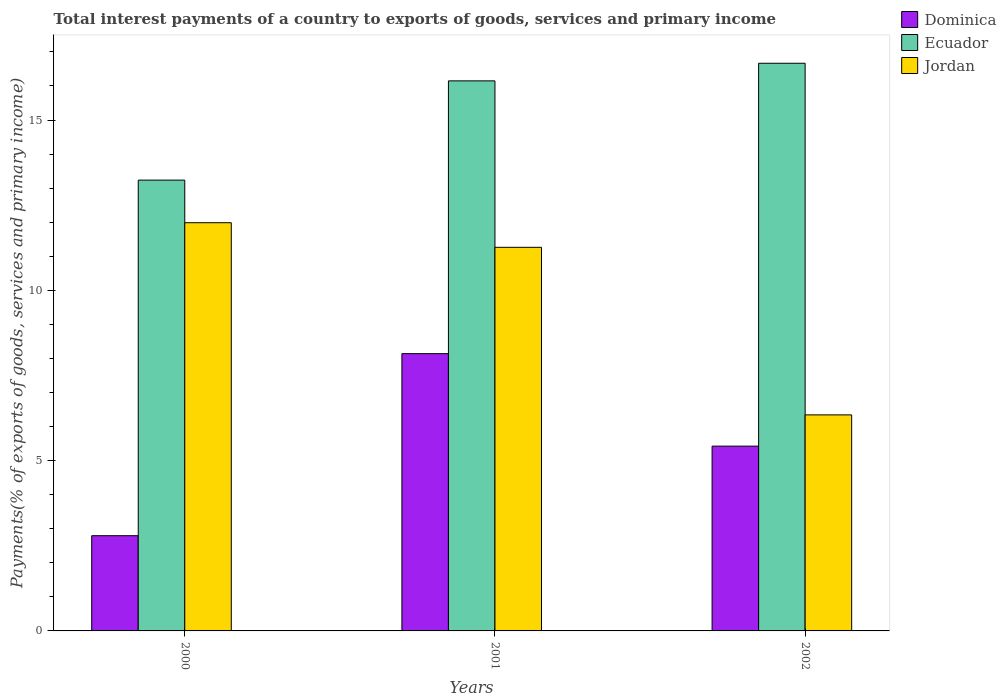How many groups of bars are there?
Ensure brevity in your answer.  3. Are the number of bars on each tick of the X-axis equal?
Your answer should be compact. Yes. How many bars are there on the 2nd tick from the right?
Keep it short and to the point. 3. What is the label of the 3rd group of bars from the left?
Make the answer very short. 2002. What is the total interest payments in Dominica in 2001?
Give a very brief answer. 8.14. Across all years, what is the maximum total interest payments in Jordan?
Ensure brevity in your answer.  11.99. Across all years, what is the minimum total interest payments in Dominica?
Make the answer very short. 2.8. What is the total total interest payments in Jordan in the graph?
Your answer should be very brief. 29.59. What is the difference between the total interest payments in Ecuador in 2001 and that in 2002?
Your answer should be compact. -0.52. What is the difference between the total interest payments in Ecuador in 2000 and the total interest payments in Jordan in 2001?
Offer a terse response. 1.97. What is the average total interest payments in Jordan per year?
Your answer should be very brief. 9.86. In the year 2002, what is the difference between the total interest payments in Dominica and total interest payments in Ecuador?
Provide a short and direct response. -11.24. What is the ratio of the total interest payments in Ecuador in 2001 to that in 2002?
Ensure brevity in your answer.  0.97. Is the total interest payments in Ecuador in 2000 less than that in 2001?
Ensure brevity in your answer.  Yes. Is the difference between the total interest payments in Dominica in 2001 and 2002 greater than the difference between the total interest payments in Ecuador in 2001 and 2002?
Your answer should be compact. Yes. What is the difference between the highest and the second highest total interest payments in Dominica?
Your answer should be compact. 2.72. What is the difference between the highest and the lowest total interest payments in Jordan?
Your response must be concise. 5.64. In how many years, is the total interest payments in Jordan greater than the average total interest payments in Jordan taken over all years?
Keep it short and to the point. 2. Is the sum of the total interest payments in Dominica in 2000 and 2002 greater than the maximum total interest payments in Ecuador across all years?
Provide a succinct answer. No. What does the 1st bar from the left in 2002 represents?
Your response must be concise. Dominica. What does the 3rd bar from the right in 2001 represents?
Your answer should be very brief. Dominica. Are all the bars in the graph horizontal?
Ensure brevity in your answer.  No. What is the difference between two consecutive major ticks on the Y-axis?
Your answer should be very brief. 5. Are the values on the major ticks of Y-axis written in scientific E-notation?
Keep it short and to the point. No. Where does the legend appear in the graph?
Your answer should be compact. Top right. How are the legend labels stacked?
Give a very brief answer. Vertical. What is the title of the graph?
Provide a succinct answer. Total interest payments of a country to exports of goods, services and primary income. Does "Least developed countries" appear as one of the legend labels in the graph?
Keep it short and to the point. No. What is the label or title of the Y-axis?
Your answer should be very brief. Payments(% of exports of goods, services and primary income). What is the Payments(% of exports of goods, services and primary income) in Dominica in 2000?
Give a very brief answer. 2.8. What is the Payments(% of exports of goods, services and primary income) of Ecuador in 2000?
Keep it short and to the point. 13.24. What is the Payments(% of exports of goods, services and primary income) in Jordan in 2000?
Your answer should be very brief. 11.99. What is the Payments(% of exports of goods, services and primary income) in Dominica in 2001?
Provide a succinct answer. 8.14. What is the Payments(% of exports of goods, services and primary income) of Ecuador in 2001?
Provide a short and direct response. 16.15. What is the Payments(% of exports of goods, services and primary income) of Jordan in 2001?
Provide a short and direct response. 11.26. What is the Payments(% of exports of goods, services and primary income) of Dominica in 2002?
Give a very brief answer. 5.43. What is the Payments(% of exports of goods, services and primary income) of Ecuador in 2002?
Provide a succinct answer. 16.67. What is the Payments(% of exports of goods, services and primary income) in Jordan in 2002?
Give a very brief answer. 6.34. Across all years, what is the maximum Payments(% of exports of goods, services and primary income) of Dominica?
Keep it short and to the point. 8.14. Across all years, what is the maximum Payments(% of exports of goods, services and primary income) of Ecuador?
Give a very brief answer. 16.67. Across all years, what is the maximum Payments(% of exports of goods, services and primary income) of Jordan?
Offer a terse response. 11.99. Across all years, what is the minimum Payments(% of exports of goods, services and primary income) of Dominica?
Keep it short and to the point. 2.8. Across all years, what is the minimum Payments(% of exports of goods, services and primary income) in Ecuador?
Give a very brief answer. 13.24. Across all years, what is the minimum Payments(% of exports of goods, services and primary income) in Jordan?
Your answer should be compact. 6.34. What is the total Payments(% of exports of goods, services and primary income) in Dominica in the graph?
Your answer should be very brief. 16.36. What is the total Payments(% of exports of goods, services and primary income) in Ecuador in the graph?
Give a very brief answer. 46.05. What is the total Payments(% of exports of goods, services and primary income) in Jordan in the graph?
Give a very brief answer. 29.59. What is the difference between the Payments(% of exports of goods, services and primary income) of Dominica in 2000 and that in 2001?
Your answer should be compact. -5.35. What is the difference between the Payments(% of exports of goods, services and primary income) of Ecuador in 2000 and that in 2001?
Offer a terse response. -2.91. What is the difference between the Payments(% of exports of goods, services and primary income) in Jordan in 2000 and that in 2001?
Offer a very short reply. 0.72. What is the difference between the Payments(% of exports of goods, services and primary income) of Dominica in 2000 and that in 2002?
Keep it short and to the point. -2.63. What is the difference between the Payments(% of exports of goods, services and primary income) in Ecuador in 2000 and that in 2002?
Ensure brevity in your answer.  -3.43. What is the difference between the Payments(% of exports of goods, services and primary income) of Jordan in 2000 and that in 2002?
Keep it short and to the point. 5.64. What is the difference between the Payments(% of exports of goods, services and primary income) in Dominica in 2001 and that in 2002?
Offer a very short reply. 2.72. What is the difference between the Payments(% of exports of goods, services and primary income) of Ecuador in 2001 and that in 2002?
Ensure brevity in your answer.  -0.52. What is the difference between the Payments(% of exports of goods, services and primary income) in Jordan in 2001 and that in 2002?
Your response must be concise. 4.92. What is the difference between the Payments(% of exports of goods, services and primary income) in Dominica in 2000 and the Payments(% of exports of goods, services and primary income) in Ecuador in 2001?
Make the answer very short. -13.35. What is the difference between the Payments(% of exports of goods, services and primary income) of Dominica in 2000 and the Payments(% of exports of goods, services and primary income) of Jordan in 2001?
Provide a short and direct response. -8.47. What is the difference between the Payments(% of exports of goods, services and primary income) of Ecuador in 2000 and the Payments(% of exports of goods, services and primary income) of Jordan in 2001?
Provide a succinct answer. 1.97. What is the difference between the Payments(% of exports of goods, services and primary income) in Dominica in 2000 and the Payments(% of exports of goods, services and primary income) in Ecuador in 2002?
Keep it short and to the point. -13.87. What is the difference between the Payments(% of exports of goods, services and primary income) of Dominica in 2000 and the Payments(% of exports of goods, services and primary income) of Jordan in 2002?
Provide a short and direct response. -3.55. What is the difference between the Payments(% of exports of goods, services and primary income) of Ecuador in 2000 and the Payments(% of exports of goods, services and primary income) of Jordan in 2002?
Give a very brief answer. 6.89. What is the difference between the Payments(% of exports of goods, services and primary income) of Dominica in 2001 and the Payments(% of exports of goods, services and primary income) of Ecuador in 2002?
Give a very brief answer. -8.53. What is the difference between the Payments(% of exports of goods, services and primary income) of Dominica in 2001 and the Payments(% of exports of goods, services and primary income) of Jordan in 2002?
Make the answer very short. 1.8. What is the difference between the Payments(% of exports of goods, services and primary income) in Ecuador in 2001 and the Payments(% of exports of goods, services and primary income) in Jordan in 2002?
Your answer should be very brief. 9.81. What is the average Payments(% of exports of goods, services and primary income) of Dominica per year?
Make the answer very short. 5.45. What is the average Payments(% of exports of goods, services and primary income) of Ecuador per year?
Offer a terse response. 15.35. What is the average Payments(% of exports of goods, services and primary income) in Jordan per year?
Give a very brief answer. 9.86. In the year 2000, what is the difference between the Payments(% of exports of goods, services and primary income) of Dominica and Payments(% of exports of goods, services and primary income) of Ecuador?
Offer a terse response. -10.44. In the year 2000, what is the difference between the Payments(% of exports of goods, services and primary income) in Dominica and Payments(% of exports of goods, services and primary income) in Jordan?
Offer a terse response. -9.19. In the year 2000, what is the difference between the Payments(% of exports of goods, services and primary income) of Ecuador and Payments(% of exports of goods, services and primary income) of Jordan?
Your answer should be compact. 1.25. In the year 2001, what is the difference between the Payments(% of exports of goods, services and primary income) of Dominica and Payments(% of exports of goods, services and primary income) of Ecuador?
Keep it short and to the point. -8.01. In the year 2001, what is the difference between the Payments(% of exports of goods, services and primary income) in Dominica and Payments(% of exports of goods, services and primary income) in Jordan?
Offer a very short reply. -3.12. In the year 2001, what is the difference between the Payments(% of exports of goods, services and primary income) of Ecuador and Payments(% of exports of goods, services and primary income) of Jordan?
Offer a very short reply. 4.89. In the year 2002, what is the difference between the Payments(% of exports of goods, services and primary income) of Dominica and Payments(% of exports of goods, services and primary income) of Ecuador?
Your answer should be compact. -11.24. In the year 2002, what is the difference between the Payments(% of exports of goods, services and primary income) in Dominica and Payments(% of exports of goods, services and primary income) in Jordan?
Make the answer very short. -0.92. In the year 2002, what is the difference between the Payments(% of exports of goods, services and primary income) of Ecuador and Payments(% of exports of goods, services and primary income) of Jordan?
Ensure brevity in your answer.  10.32. What is the ratio of the Payments(% of exports of goods, services and primary income) of Dominica in 2000 to that in 2001?
Ensure brevity in your answer.  0.34. What is the ratio of the Payments(% of exports of goods, services and primary income) in Ecuador in 2000 to that in 2001?
Offer a terse response. 0.82. What is the ratio of the Payments(% of exports of goods, services and primary income) in Jordan in 2000 to that in 2001?
Ensure brevity in your answer.  1.06. What is the ratio of the Payments(% of exports of goods, services and primary income) in Dominica in 2000 to that in 2002?
Make the answer very short. 0.52. What is the ratio of the Payments(% of exports of goods, services and primary income) of Ecuador in 2000 to that in 2002?
Ensure brevity in your answer.  0.79. What is the ratio of the Payments(% of exports of goods, services and primary income) of Jordan in 2000 to that in 2002?
Your response must be concise. 1.89. What is the ratio of the Payments(% of exports of goods, services and primary income) in Dominica in 2001 to that in 2002?
Provide a short and direct response. 1.5. What is the ratio of the Payments(% of exports of goods, services and primary income) of Ecuador in 2001 to that in 2002?
Offer a very short reply. 0.97. What is the ratio of the Payments(% of exports of goods, services and primary income) in Jordan in 2001 to that in 2002?
Your answer should be very brief. 1.78. What is the difference between the highest and the second highest Payments(% of exports of goods, services and primary income) in Dominica?
Offer a terse response. 2.72. What is the difference between the highest and the second highest Payments(% of exports of goods, services and primary income) in Ecuador?
Offer a very short reply. 0.52. What is the difference between the highest and the second highest Payments(% of exports of goods, services and primary income) of Jordan?
Your answer should be very brief. 0.72. What is the difference between the highest and the lowest Payments(% of exports of goods, services and primary income) of Dominica?
Give a very brief answer. 5.35. What is the difference between the highest and the lowest Payments(% of exports of goods, services and primary income) of Ecuador?
Your answer should be very brief. 3.43. What is the difference between the highest and the lowest Payments(% of exports of goods, services and primary income) in Jordan?
Provide a short and direct response. 5.64. 